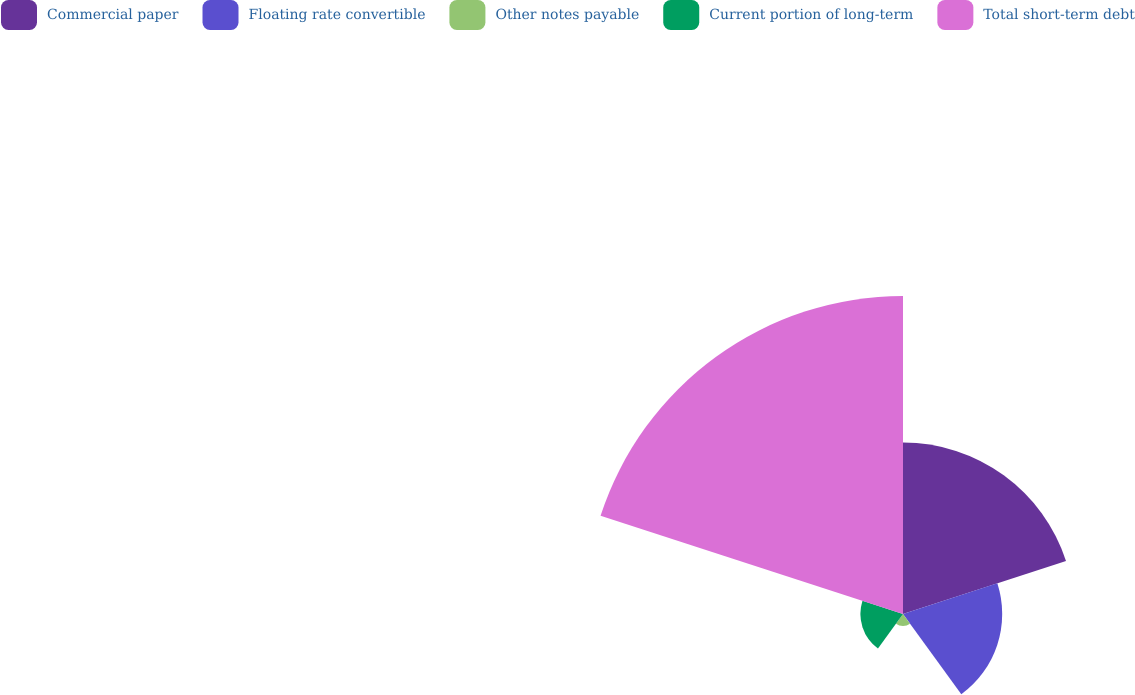Convert chart to OTSL. <chart><loc_0><loc_0><loc_500><loc_500><pie_chart><fcel>Commercial paper<fcel>Floating rate convertible<fcel>Other notes payable<fcel>Current portion of long-term<fcel>Total short-term debt<nl><fcel>26.65%<fcel>15.42%<fcel>1.86%<fcel>6.62%<fcel>49.44%<nl></chart> 